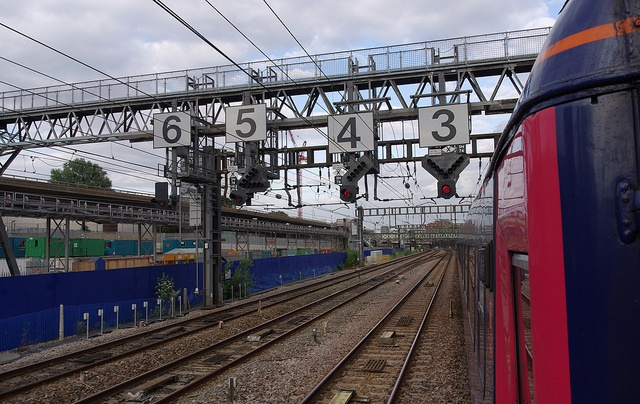Describe the objects in this image and their specific colors. I can see train in lightgray, black, brown, navy, and maroon tones, traffic light in lightgray, black, maroon, and purple tones, traffic light in lightgray, black, maroon, and brown tones, traffic light in lightgray, black, maroon, and brown tones, and traffic light in lightgray, black, gray, maroon, and purple tones in this image. 